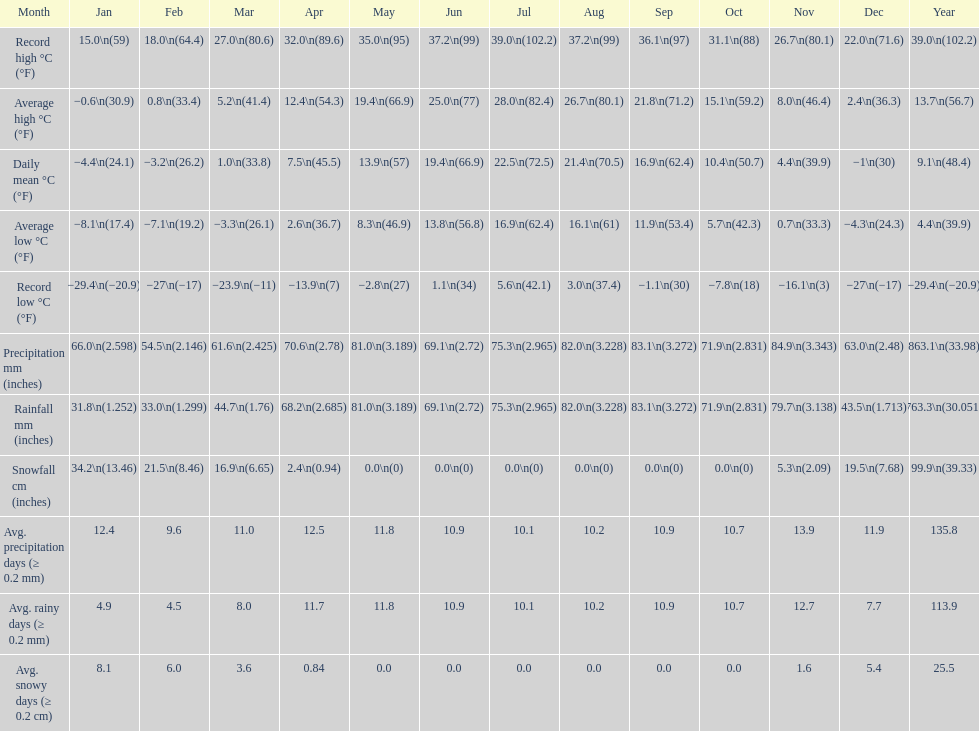How many months experienced a record high temperature of more than 1 11. 